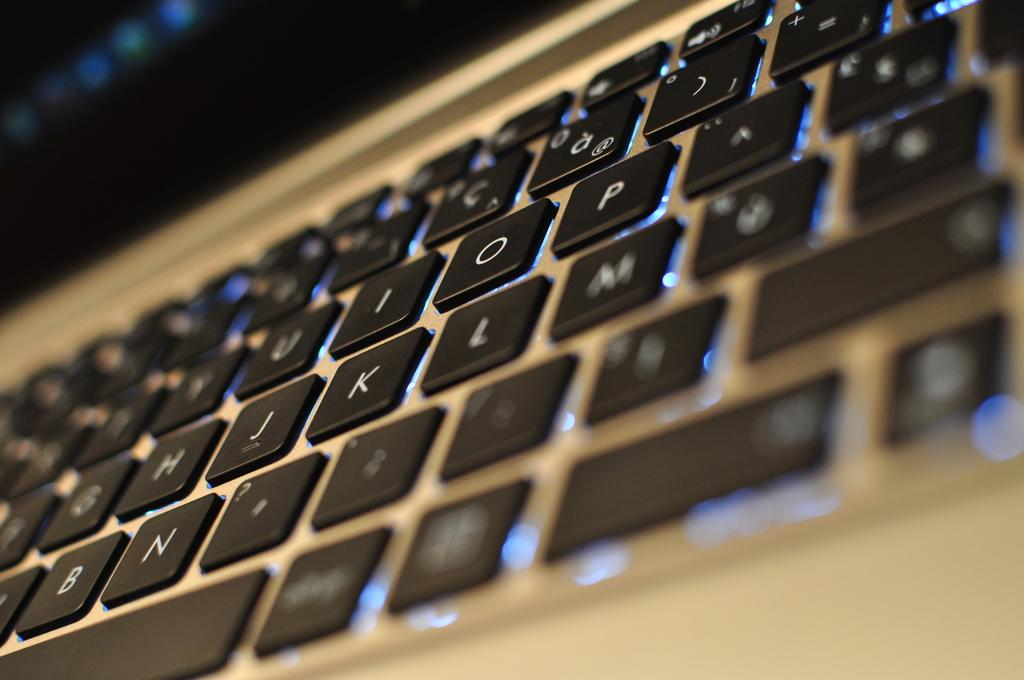<image>
Summarize the visual content of the image. A keyboard with the keypad I, O, P, J, K and L prominently showing. 